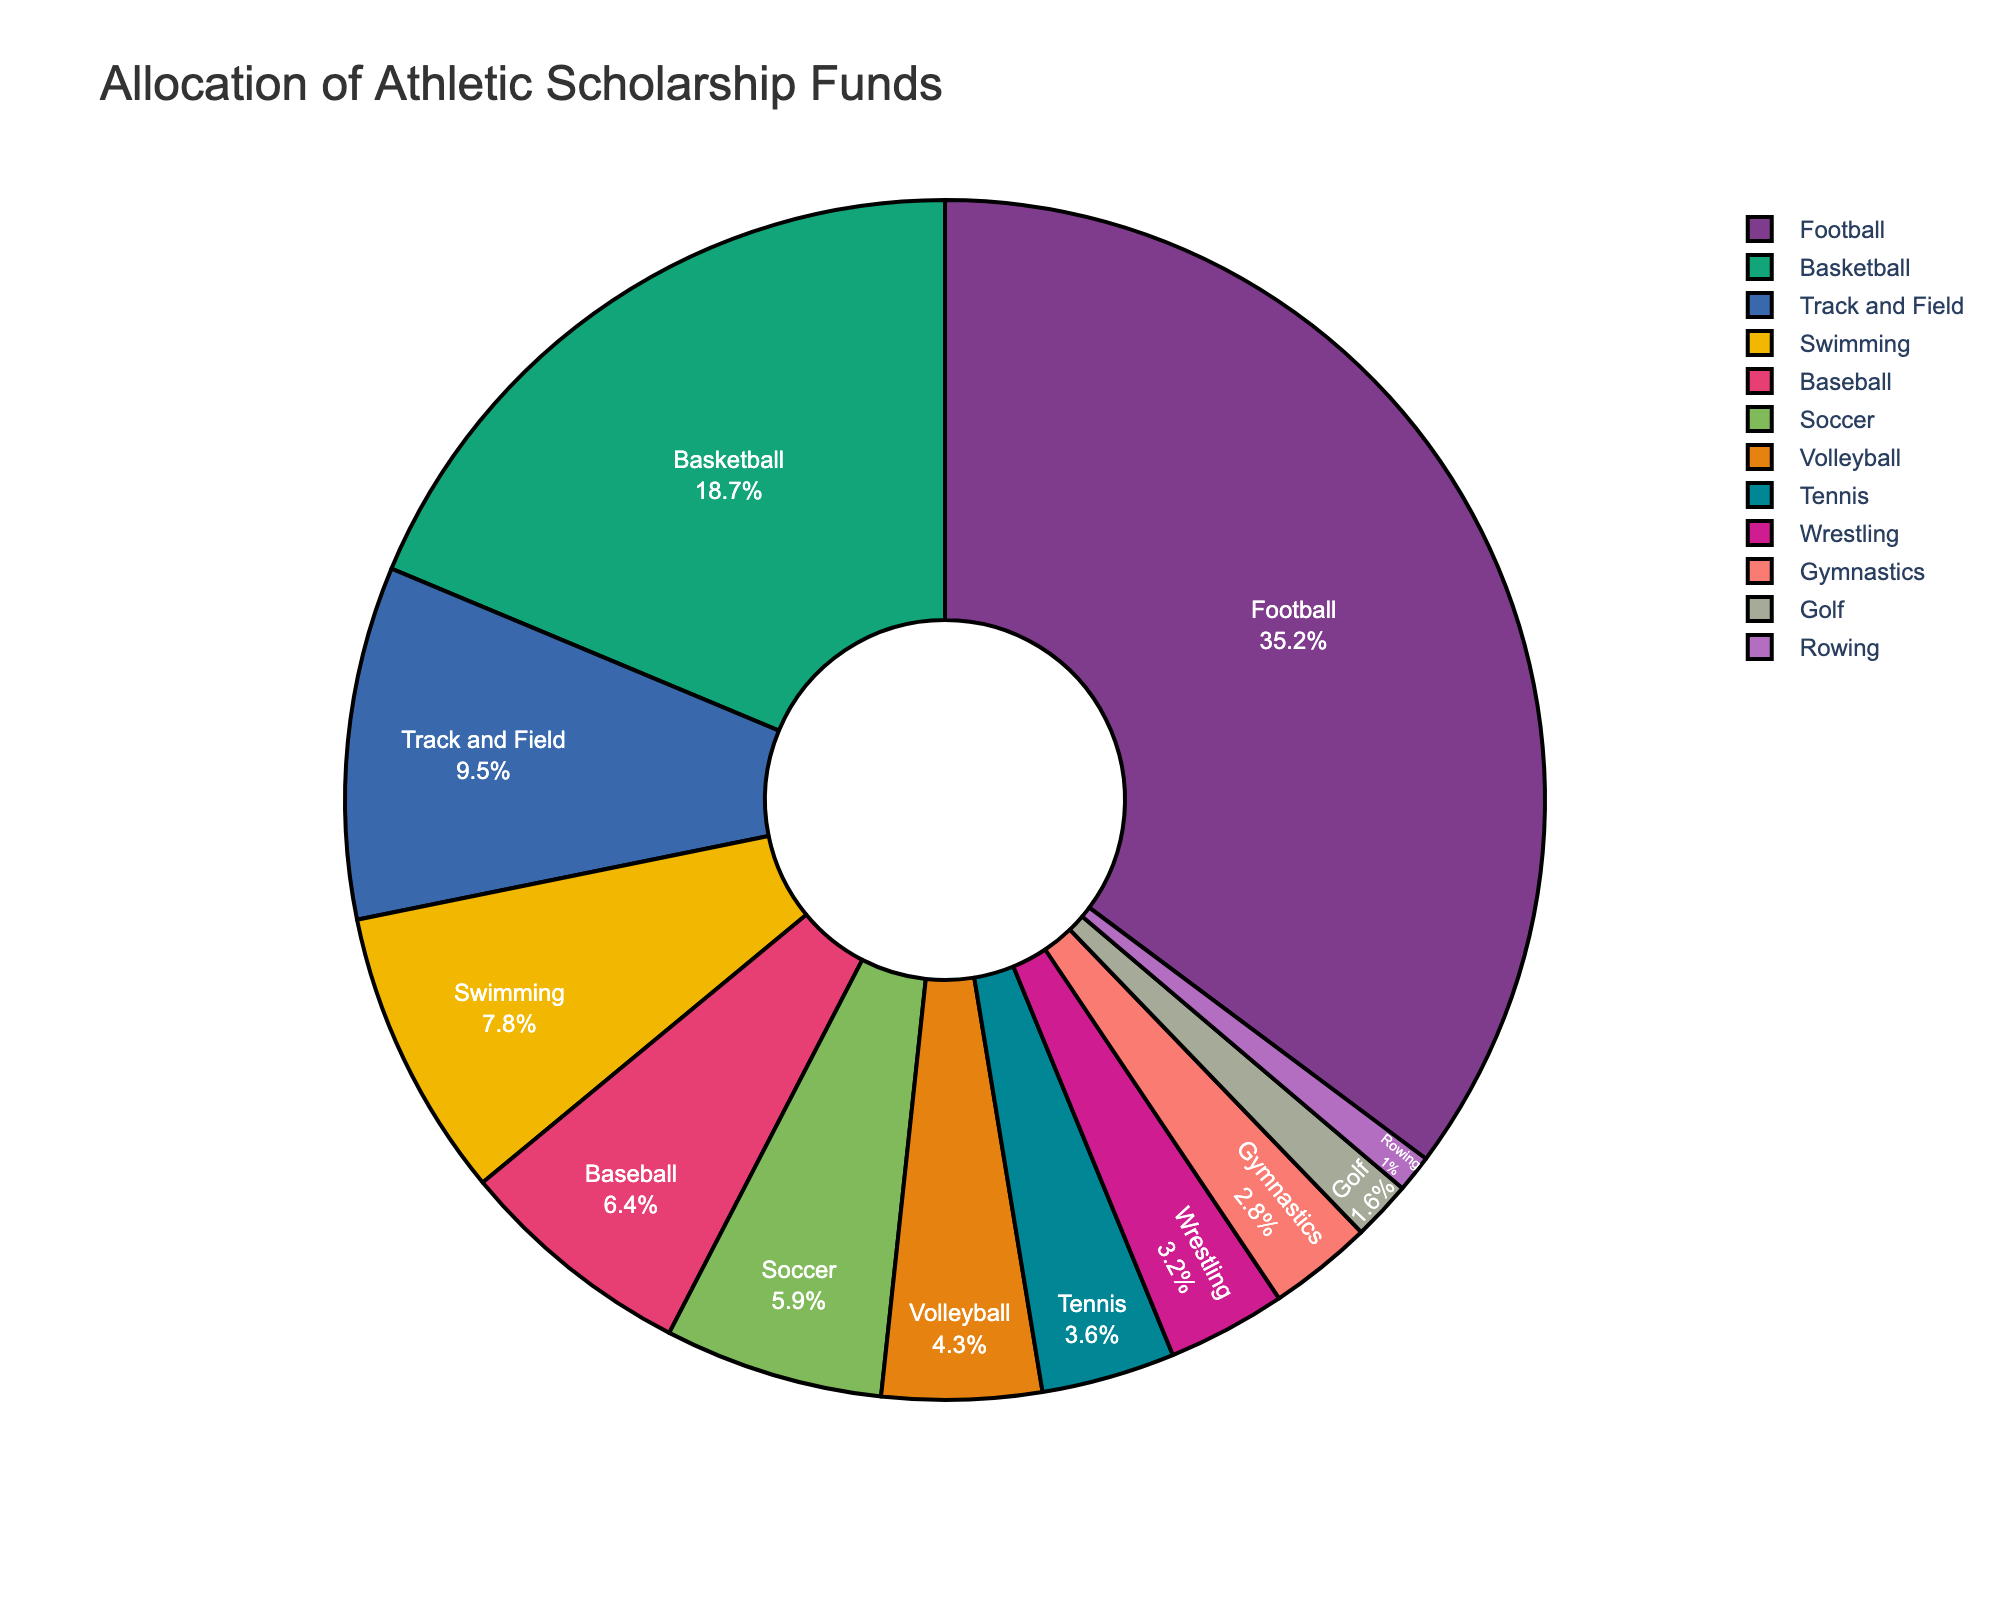What's the sum of the scholarship allocation percentages for Football and Basketball? From the pie chart, the allocation for Football is 35.2% and for Basketball is 18.7%. Summing these gives 35.2 + 18.7 = 53.9%.
Answer: 53.9% Which sport receives a higher percentage of scholarship funds, Soccer or Baseball? Soccer receives 5.9% while Baseball receives 6.4%. Hence, Baseball receives a higher percentage of scholarship funds than Soccer.
Answer: Baseball What is the difference in the percentage allocation between Volleyball and Tennis? The allocation for Volleyball is 4.3% and for Tennis, it is 3.6%. The difference is 4.3 - 3.6 = 0.7%.
Answer: 0.7% Is Track and Field or Wrestling allocated more scholarship funds? Track and Field is allocated 9.5% while Wrestling is allocated 3.2%. Hence, Track and Field is allocated more funds.
Answer: Track and Field Combine the fund allocations percentages for Gymnastics, Rowing, and Golf. What is the total? The allocations are Gymnastics 2.8%, Rowing 1.0%, and Golf 1.6%. Adding these gives 2.8 + 1.0 + 1.6 = 5.4%.
Answer: 5.4% Among the sports listed, which sport has the smallest allocation of scholarship funds? According to the pie chart, Rowing gets the smallest allocation at 1.0%.
Answer: Rowing Consider the colors used in the pie chart. Which sport is represented by the color close to blue? The colors in the pie chart can vary depending on the color scheme, but typically, Track and Field might be shown with a blueish color. It's important to check the chart to confirm.
Answer: Track and Field (if typically blue) On average, what is the scholarship allocation percentage across all sports? There are 12 sports listed in the data. Sum all the percentages: 35.2 + 18.7 + 9.5 + 7.8 + 6.4 + 5.9 + 4.3 + 3.6 + 3.2 + 2.8 + 1.6 + 1.0 = 100%. Dividing by the number of items (12) we get 100 / 12 ≈ 8.33%.
Answer: 8.33% How does the scholarship allocation for Tennis compare to Volleyball? Tennis has an allocation of 3.6% and Volleyball has 4.3%. Therefore, Volleyball's allocation is higher than Tennis by 0.7%.
Answer: Volleyball has higher allocation by 0.7% 